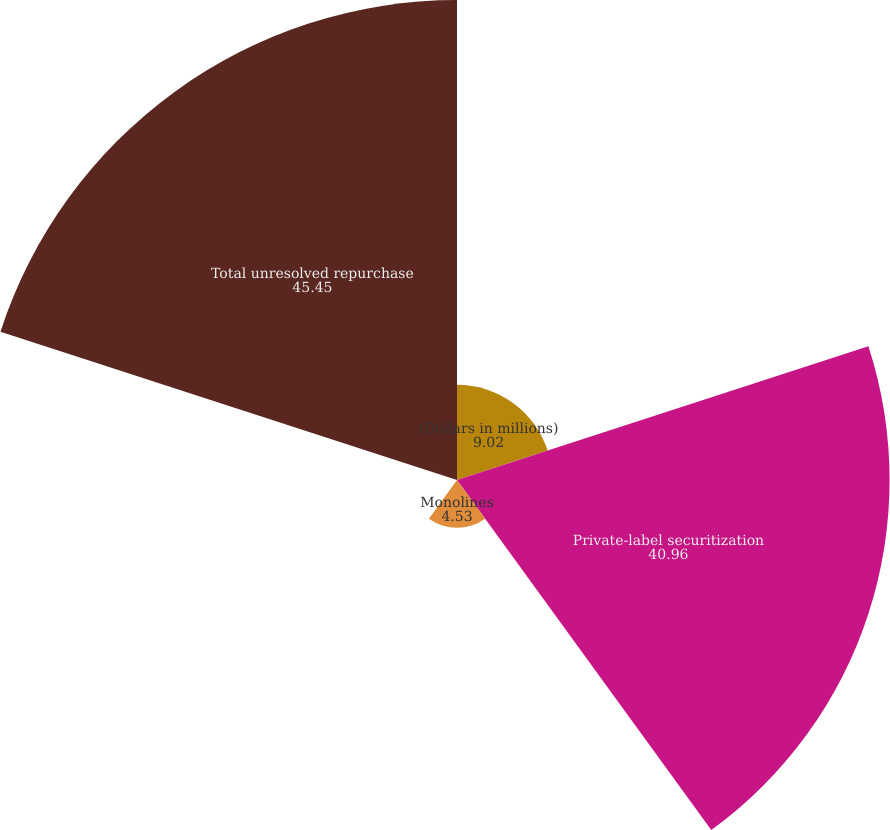Convert chart to OTSL. <chart><loc_0><loc_0><loc_500><loc_500><pie_chart><fcel>(Dollars in millions)<fcel>Private-label securitization<fcel>Monolines<fcel>GSEs<fcel>Total unresolved repurchase<nl><fcel>9.02%<fcel>40.96%<fcel>4.53%<fcel>0.04%<fcel>45.45%<nl></chart> 